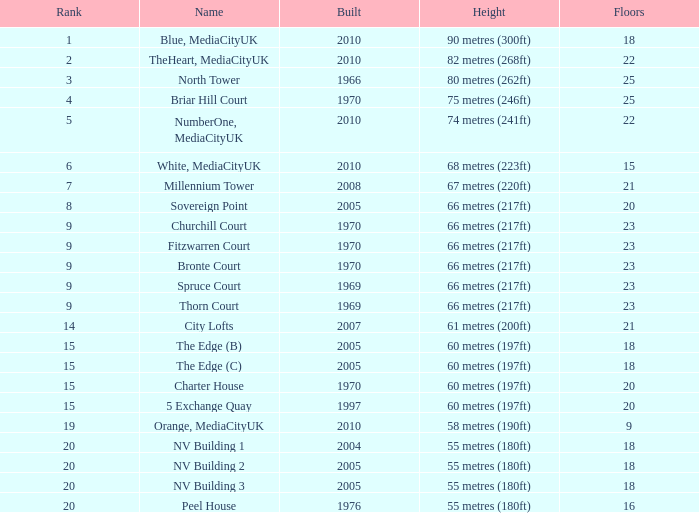What is the elevation, when position is under 20, when levels is over 9, when constructed is 2005, and when title is the edge (c)? 60 metres (197ft). Would you mind parsing the complete table? {'header': ['Rank', 'Name', 'Built', 'Height', 'Floors'], 'rows': [['1', 'Blue, MediaCityUK', '2010', '90 metres (300ft)', '18'], ['2', 'TheHeart, MediaCityUK', '2010', '82 metres (268ft)', '22'], ['3', 'North Tower', '1966', '80 metres (262ft)', '25'], ['4', 'Briar Hill Court', '1970', '75 metres (246ft)', '25'], ['5', 'NumberOne, MediaCityUK', '2010', '74 metres (241ft)', '22'], ['6', 'White, MediaCityUK', '2010', '68 metres (223ft)', '15'], ['7', 'Millennium Tower', '2008', '67 metres (220ft)', '21'], ['8', 'Sovereign Point', '2005', '66 metres (217ft)', '20'], ['9', 'Churchill Court', '1970', '66 metres (217ft)', '23'], ['9', 'Fitzwarren Court', '1970', '66 metres (217ft)', '23'], ['9', 'Bronte Court', '1970', '66 metres (217ft)', '23'], ['9', 'Spruce Court', '1969', '66 metres (217ft)', '23'], ['9', 'Thorn Court', '1969', '66 metres (217ft)', '23'], ['14', 'City Lofts', '2007', '61 metres (200ft)', '21'], ['15', 'The Edge (B)', '2005', '60 metres (197ft)', '18'], ['15', 'The Edge (C)', '2005', '60 metres (197ft)', '18'], ['15', 'Charter House', '1970', '60 metres (197ft)', '20'], ['15', '5 Exchange Quay', '1997', '60 metres (197ft)', '20'], ['19', 'Orange, MediaCityUK', '2010', '58 metres (190ft)', '9'], ['20', 'NV Building 1', '2004', '55 metres (180ft)', '18'], ['20', 'NV Building 2', '2005', '55 metres (180ft)', '18'], ['20', 'NV Building 3', '2005', '55 metres (180ft)', '18'], ['20', 'Peel House', '1976', '55 metres (180ft)', '16']]} 